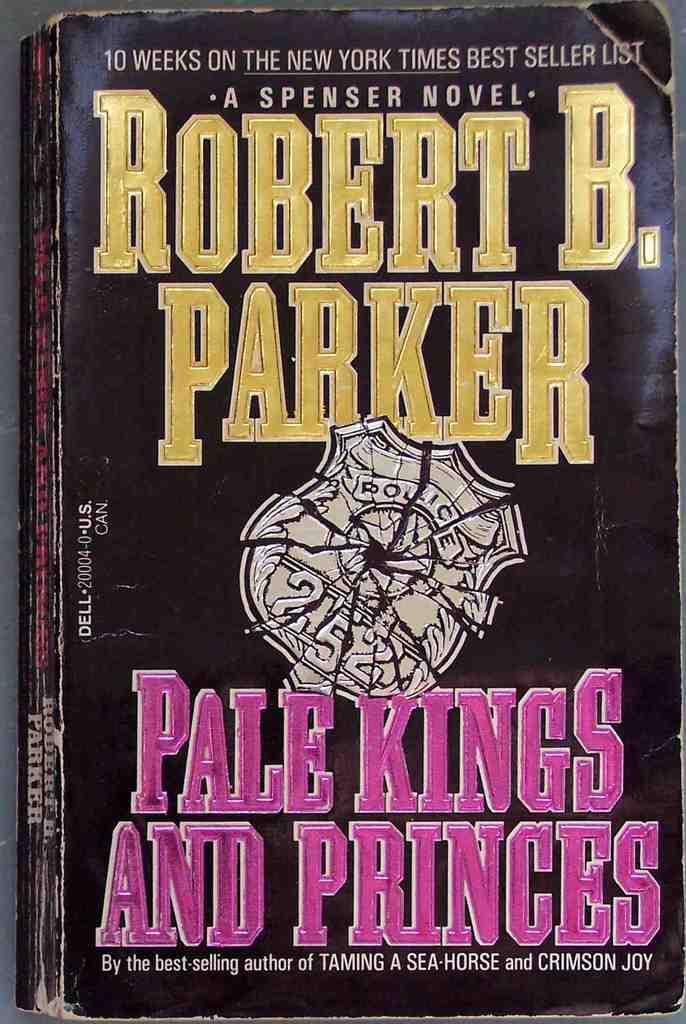Besides this novel, what is another book written by this author?
Your response must be concise. Taming a sea horse. 